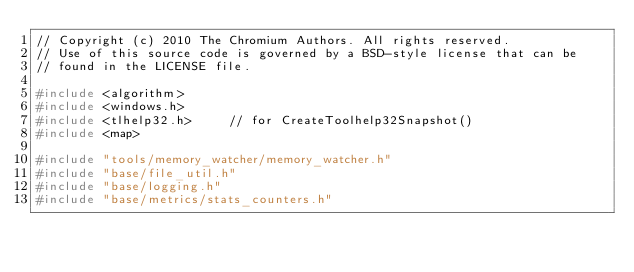Convert code to text. <code><loc_0><loc_0><loc_500><loc_500><_C++_>// Copyright (c) 2010 The Chromium Authors. All rights reserved.
// Use of this source code is governed by a BSD-style license that can be
// found in the LICENSE file.

#include <algorithm>
#include <windows.h>
#include <tlhelp32.h>     // for CreateToolhelp32Snapshot()
#include <map>

#include "tools/memory_watcher/memory_watcher.h"
#include "base/file_util.h"
#include "base/logging.h"
#include "base/metrics/stats_counters.h"</code> 